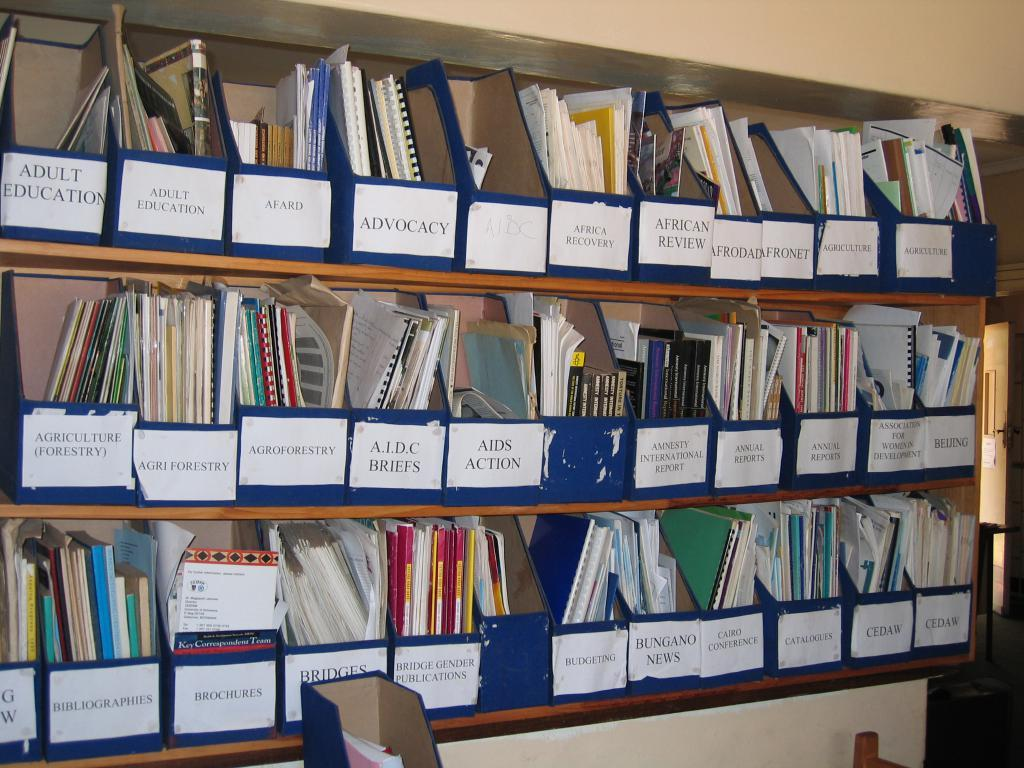Provide a one-sentence caption for the provided image. A shelf of binders that have been organized into named boxes some for Adult Education. 